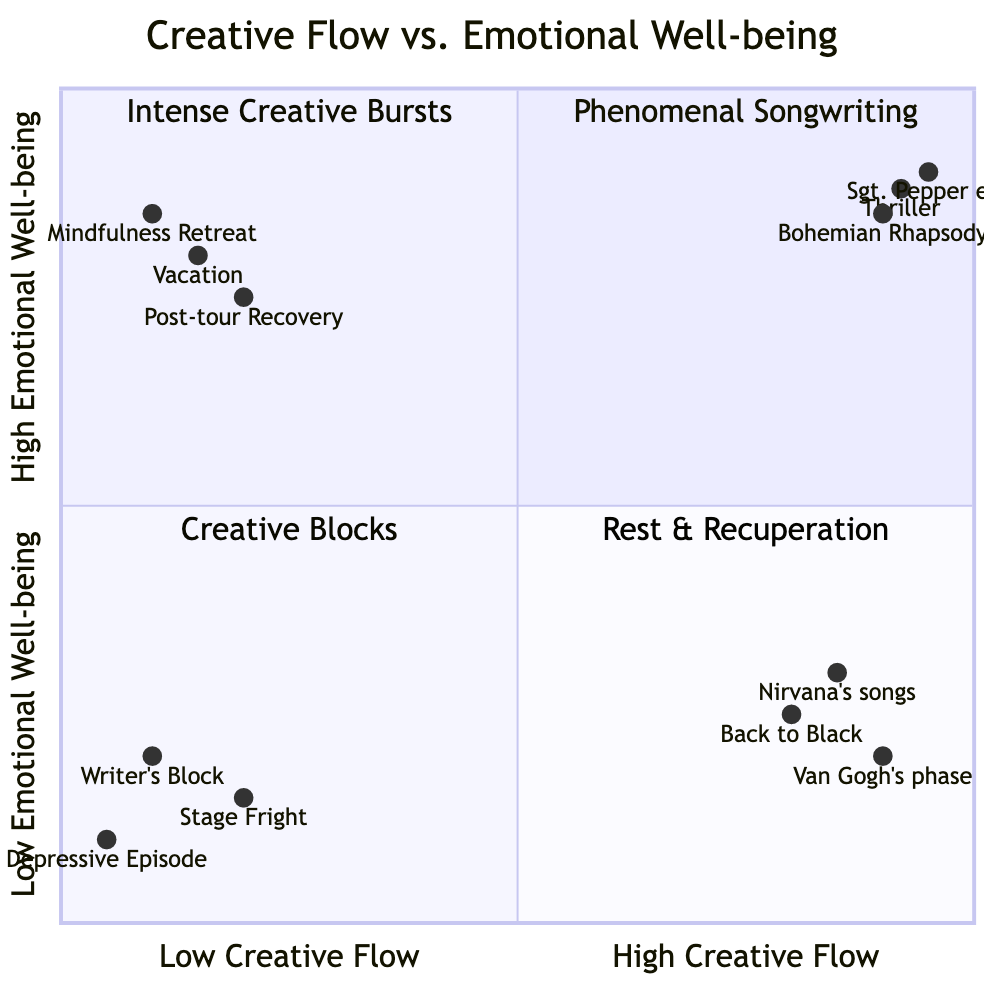What is the highest noted example in the "High Creative Flow & High Emotional Well-being" quadrant? The quadrant displays the examples of 'Bohemian Rhapsody', 'Sgt. Pepper era', and 'Thriller'. The highest noted example is 'Sgt. Pepper era' due to its coordinates being the highest on both axes.
Answer: Sgt. Pepper era Which artistic work is plotted in the "Low Creative Flow & Low Emotional Well-being" quadrant? The quadrant shows 'Writer’s Block', 'Depressive Episode', and 'Stage Fright' as examples. Any of these can be considered, but 'Writer’s Block' is a clear representation of this quadrant.
Answer: Writer's Block What is the emotional well-being score for 'Nirvana's songs'? The score displayed for 'Nirvana's songs' is confirmed by its coordinates; examining the y-axis, it shows a value of 0.3.
Answer: 0.3 How many examples are in the "High Creative Flow & Low Emotional Well-being" quadrant? The quadrant lists three examples: 'Kurt Cobain's Songwriting for Nirvana', 'Amy Winehouse Album Back to Black', and 'Vincent van Gogh's Most Productive Phase'. Thus, there are three examples total.
Answer: 3 Which quadrant contains examples of artistic work related to recovery processes? The "Low Creative Flow & High Emotional Well-being" quadrant contains descriptions and examples that relate to recovery, including 'Post-tour Recovery', 'Vacation', and 'Mindfulness Retreat'.
Answer: Low Creative Flow & High Emotional Well-being What is the relationship between creative flow and emotional well-being for 'Back to Black'? For 'Back to Black', it is located in the "High Creative Flow & Low Emotional Well-being" quadrant, indicating a high level of creative output coupled with low emotional well-being.
Answer: High Creative Flow & Low Emotional Well-being Which example has the lowest score for emotional well-being? The lowest score shown on the y-axis is attributed to 'Depressive Episode', as its coordinates indicate the lowest emotional well-being score.
Answer: Depressive Episode What characteristic is described in the "Low Creative Flow & High Emotional Well-being" quadrant? The description in this quadrant emphasizes rest and recuperation periods, mental health, and self-care activities.
Answer: Rest & Recuperation Periods How are the examples in "High Creative Flow & High Emotional Well-being" quadrant described? The quadrant describes the examples with terms like phenomenal songwriting periods, uplifting performances, and balanced creative output and mental health.
Answer: Phenomenal Songwriting Periods 